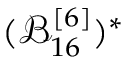<formula> <loc_0><loc_0><loc_500><loc_500>( \mathcal { B } _ { 1 6 } ^ { [ 6 ] } ) ^ { * }</formula> 